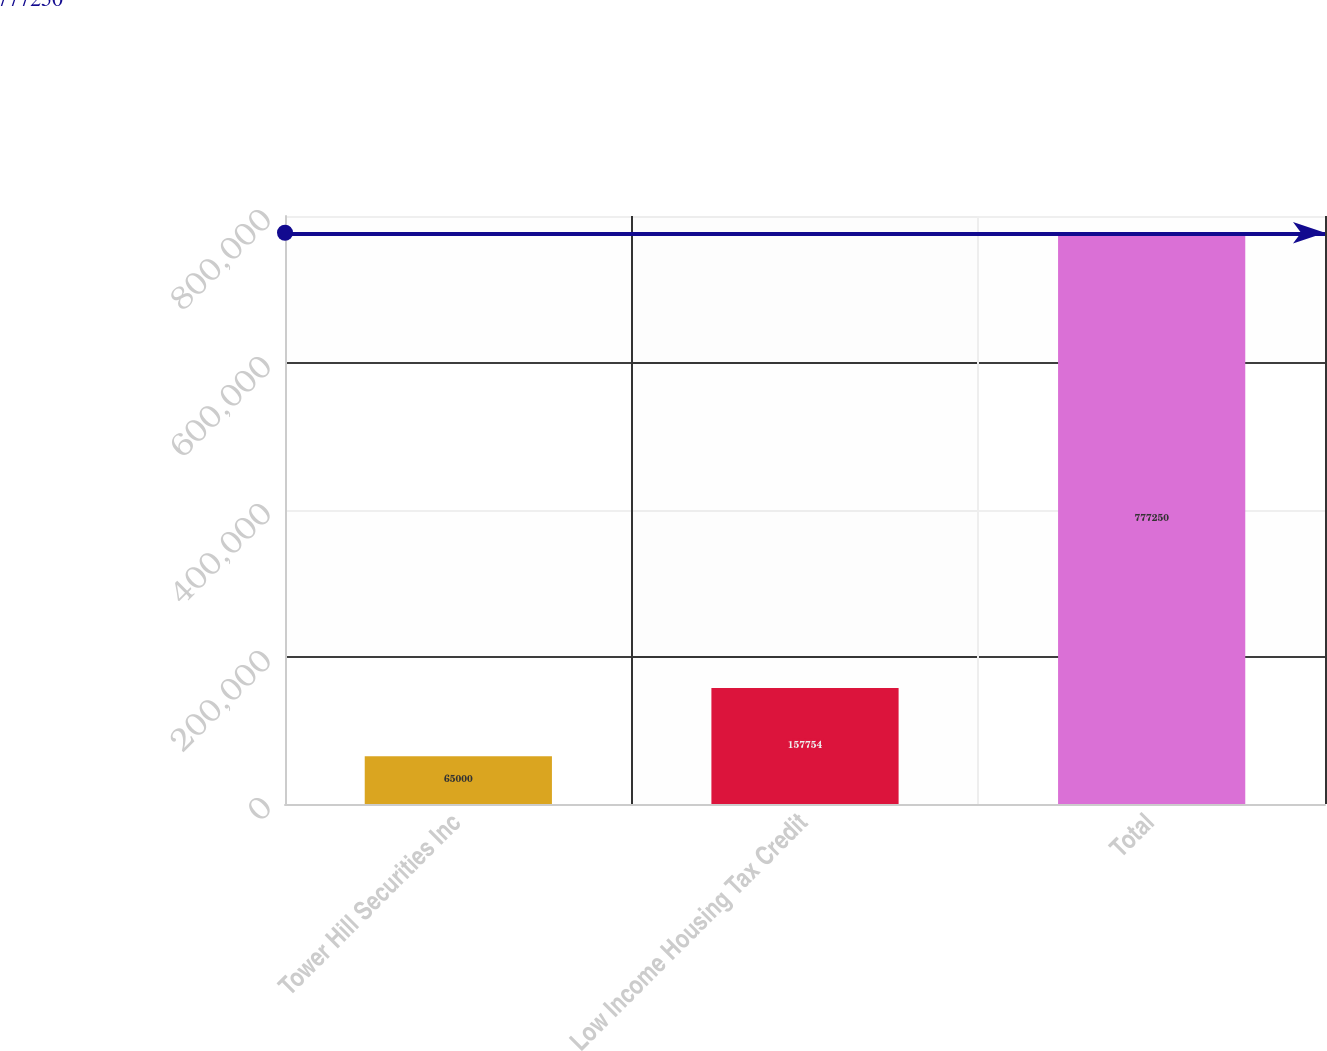Convert chart to OTSL. <chart><loc_0><loc_0><loc_500><loc_500><bar_chart><fcel>Tower Hill Securities Inc<fcel>Low Income Housing Tax Credit<fcel>Total<nl><fcel>65000<fcel>157754<fcel>777250<nl></chart> 